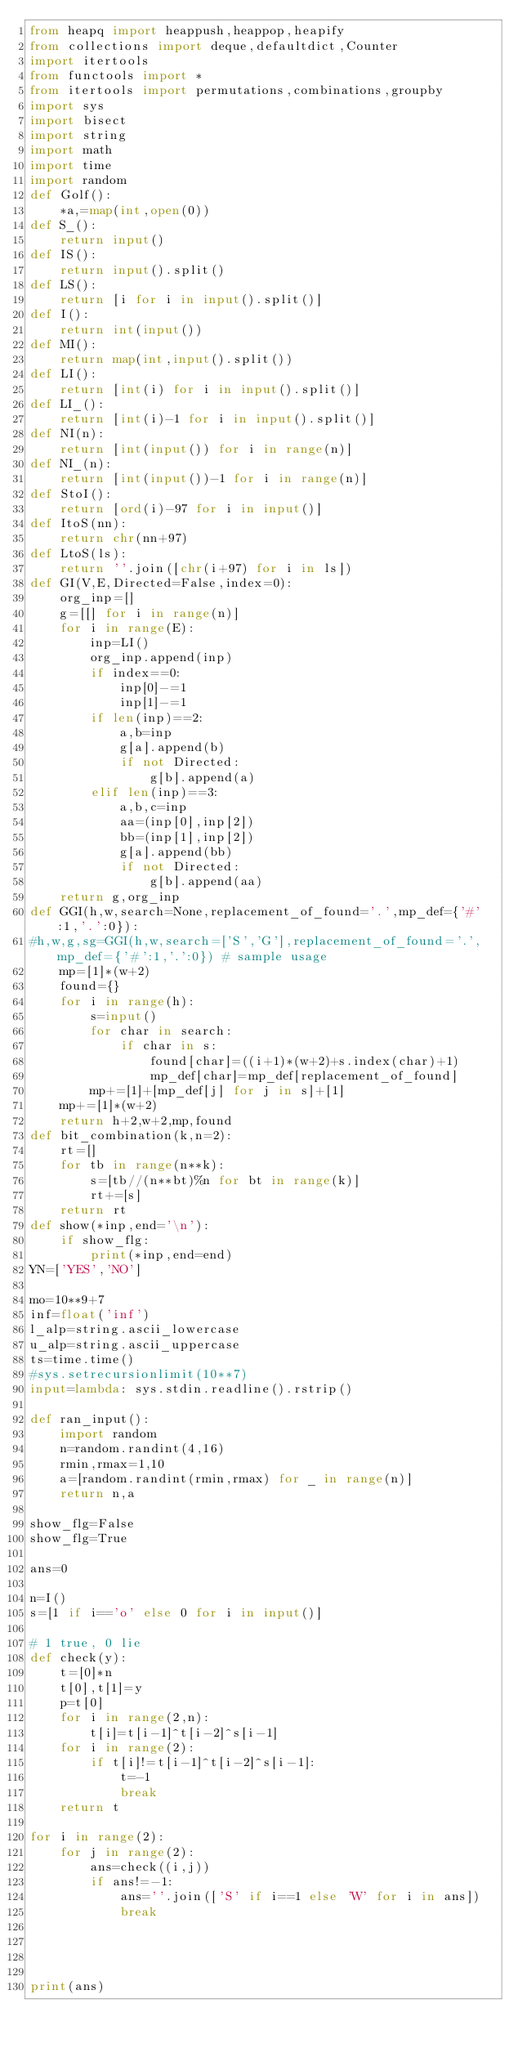Convert code to text. <code><loc_0><loc_0><loc_500><loc_500><_Python_>from heapq import heappush,heappop,heapify
from collections import deque,defaultdict,Counter
import itertools
from functools import *
from itertools import permutations,combinations,groupby
import sys
import bisect
import string
import math
import time
import random
def Golf():
    *a,=map(int,open(0))
def S_():
    return input()
def IS():
    return input().split()
def LS():
    return [i for i in input().split()]
def I():
    return int(input())
def MI():
    return map(int,input().split())
def LI():
    return [int(i) for i in input().split()]
def LI_():
    return [int(i)-1 for i in input().split()]
def NI(n):
    return [int(input()) for i in range(n)]
def NI_(n):
    return [int(input())-1 for i in range(n)]
def StoI():
    return [ord(i)-97 for i in input()]
def ItoS(nn):
    return chr(nn+97)
def LtoS(ls):
    return ''.join([chr(i+97) for i in ls])
def GI(V,E,Directed=False,index=0):
    org_inp=[]
    g=[[] for i in range(n)]
    for i in range(E):
        inp=LI()
        org_inp.append(inp)
        if index==0:
            inp[0]-=1
            inp[1]-=1
        if len(inp)==2:
            a,b=inp
            g[a].append(b)
            if not Directed:
                g[b].append(a)
        elif len(inp)==3:
            a,b,c=inp
            aa=(inp[0],inp[2])
            bb=(inp[1],inp[2])
            g[a].append(bb)
            if not Directed:
                g[b].append(aa)
    return g,org_inp
def GGI(h,w,search=None,replacement_of_found='.',mp_def={'#':1,'.':0}):
#h,w,g,sg=GGI(h,w,search=['S','G'],replacement_of_found='.',mp_def={'#':1,'.':0}) # sample usage
    mp=[1]*(w+2)
    found={}
    for i in range(h):
        s=input()
        for char in search:
            if char in s:
                found[char]=((i+1)*(w+2)+s.index(char)+1)
                mp_def[char]=mp_def[replacement_of_found]
        mp+=[1]+[mp_def[j] for j in s]+[1]
    mp+=[1]*(w+2)
    return h+2,w+2,mp,found
def bit_combination(k,n=2):
    rt=[]
    for tb in range(n**k):
        s=[tb//(n**bt)%n for bt in range(k)]
        rt+=[s]
    return rt
def show(*inp,end='\n'):
    if show_flg:
        print(*inp,end=end)
YN=['YES','NO']

mo=10**9+7
inf=float('inf')
l_alp=string.ascii_lowercase
u_alp=string.ascii_uppercase
ts=time.time()
#sys.setrecursionlimit(10**7)
input=lambda: sys.stdin.readline().rstrip()
 
def ran_input():
    import random
    n=random.randint(4,16)
    rmin,rmax=1,10
    a=[random.randint(rmin,rmax) for _ in range(n)]
    return n,a

show_flg=False
show_flg=True

ans=0

n=I()
s=[1 if i=='o' else 0 for i in input()]

# 1 true, 0 lie
def check(y):
    t=[0]*n
    t[0],t[1]=y
    p=t[0]
    for i in range(2,n):
        t[i]=t[i-1]^t[i-2]^s[i-1]
    for i in range(2):
        if t[i]!=t[i-1]^t[i-2]^s[i-1]:
            t=-1
            break
    return t

for i in range(2):
    for j in range(2):
        ans=check((i,j))
        if ans!=-1:
            ans=''.join(['S' if i==1 else 'W' for i in ans])
            break




print(ans)


</code> 